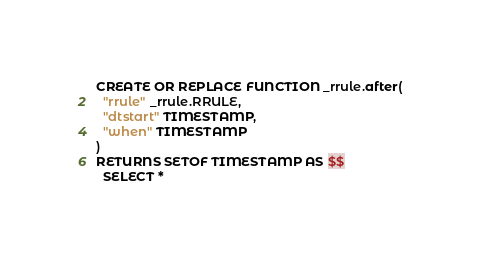Convert code to text. <code><loc_0><loc_0><loc_500><loc_500><_SQL_>

CREATE OR REPLACE FUNCTION _rrule.after(
  "rrule" _rrule.RRULE,
  "dtstart" TIMESTAMP,
  "when" TIMESTAMP
)
RETURNS SETOF TIMESTAMP AS $$
  SELECT *</code> 